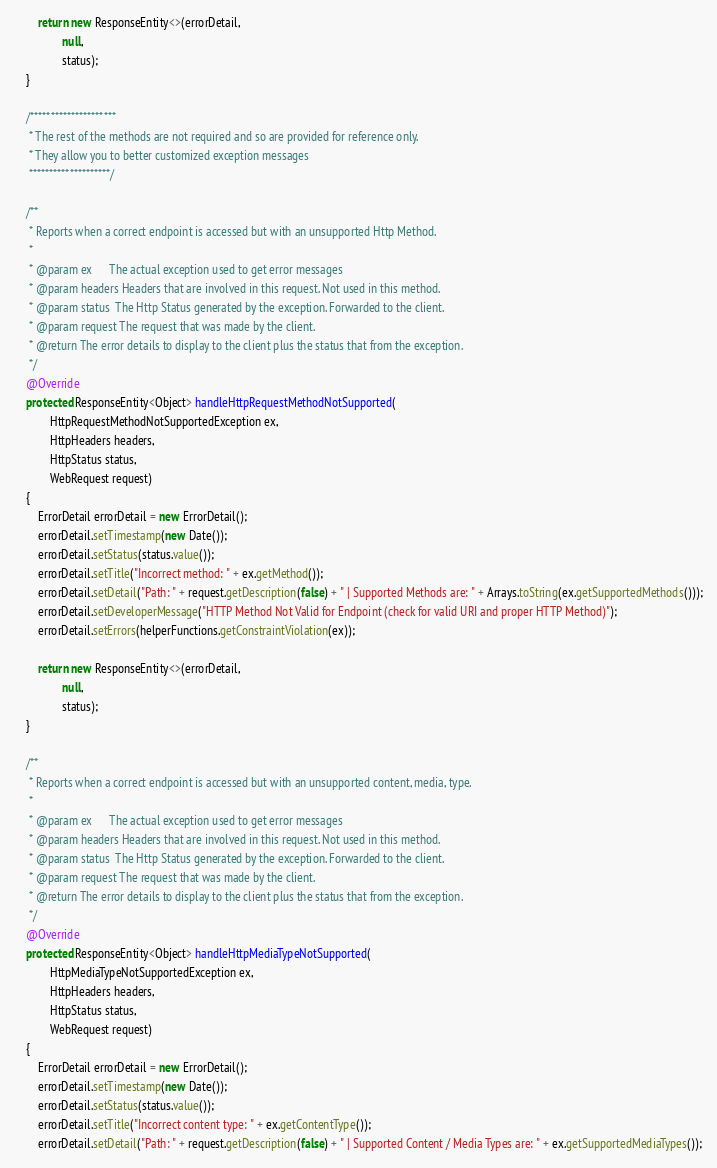Convert code to text. <code><loc_0><loc_0><loc_500><loc_500><_Java_>        return new ResponseEntity<>(errorDetail,
                null,
                status);
    }

    /*********************
     * The rest of the methods are not required and so are provided for reference only.
     * They allow you to better customized exception messages
     ********************/

    /**
     * Reports when a correct endpoint is accessed but with an unsupported Http Method.
     *
     * @param ex      The actual exception used to get error messages
     * @param headers Headers that are involved in this request. Not used in this method.
     * @param status  The Http Status generated by the exception. Forwarded to the client.
     * @param request The request that was made by the client.
     * @return The error details to display to the client plus the status that from the exception.
     */
    @Override
    protected ResponseEntity<Object> handleHttpRequestMethodNotSupported(
            HttpRequestMethodNotSupportedException ex,
            HttpHeaders headers,
            HttpStatus status,
            WebRequest request)
    {
        ErrorDetail errorDetail = new ErrorDetail();
        errorDetail.setTimestamp(new Date());
        errorDetail.setStatus(status.value());
        errorDetail.setTitle("Incorrect method: " + ex.getMethod());
        errorDetail.setDetail("Path: " + request.getDescription(false) + " | Supported Methods are: " + Arrays.toString(ex.getSupportedMethods()));
        errorDetail.setDeveloperMessage("HTTP Method Not Valid for Endpoint (check for valid URI and proper HTTP Method)");
        errorDetail.setErrors(helperFunctions.getConstraintViolation(ex));

        return new ResponseEntity<>(errorDetail,
                null,
                status);
    }

    /**
     * Reports when a correct endpoint is accessed but with an unsupported content, media, type.
     *
     * @param ex      The actual exception used to get error messages
     * @param headers Headers that are involved in this request. Not used in this method.
     * @param status  The Http Status generated by the exception. Forwarded to the client.
     * @param request The request that was made by the client.
     * @return The error details to display to the client plus the status that from the exception.
     */
    @Override
    protected ResponseEntity<Object> handleHttpMediaTypeNotSupported(
            HttpMediaTypeNotSupportedException ex,
            HttpHeaders headers,
            HttpStatus status,
            WebRequest request)
    {
        ErrorDetail errorDetail = new ErrorDetail();
        errorDetail.setTimestamp(new Date());
        errorDetail.setStatus(status.value());
        errorDetail.setTitle("Incorrect content type: " + ex.getContentType());
        errorDetail.setDetail("Path: " + request.getDescription(false) + " | Supported Content / Media Types are: " + ex.getSupportedMediaTypes());</code> 